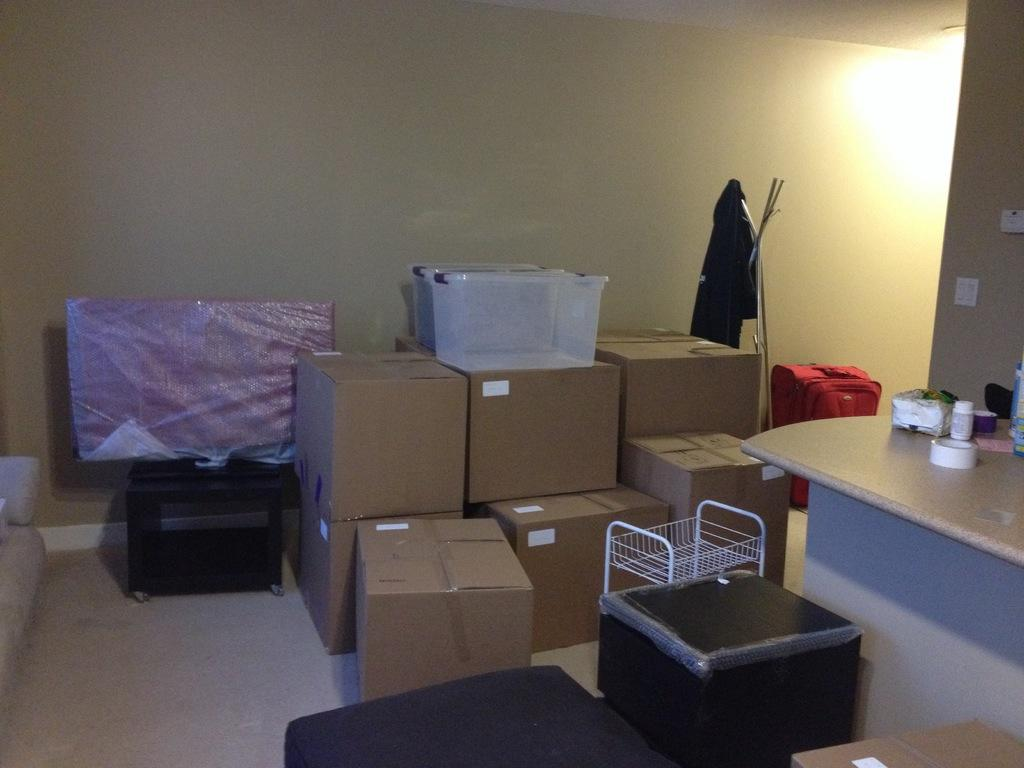What objects are visible in the image? There are boxes and a desk in the image. What is the primary function of the desk? The primary function of the desk is to provide a surface for placing objects. What can be seen on the desk in the image? There are some things placed on the desk. What color is the cloud in the image? There is no cloud present in the image. How does the person in the image swim to the boxes? There is no person present in the image, and therefore no swimming activity can be observed. 